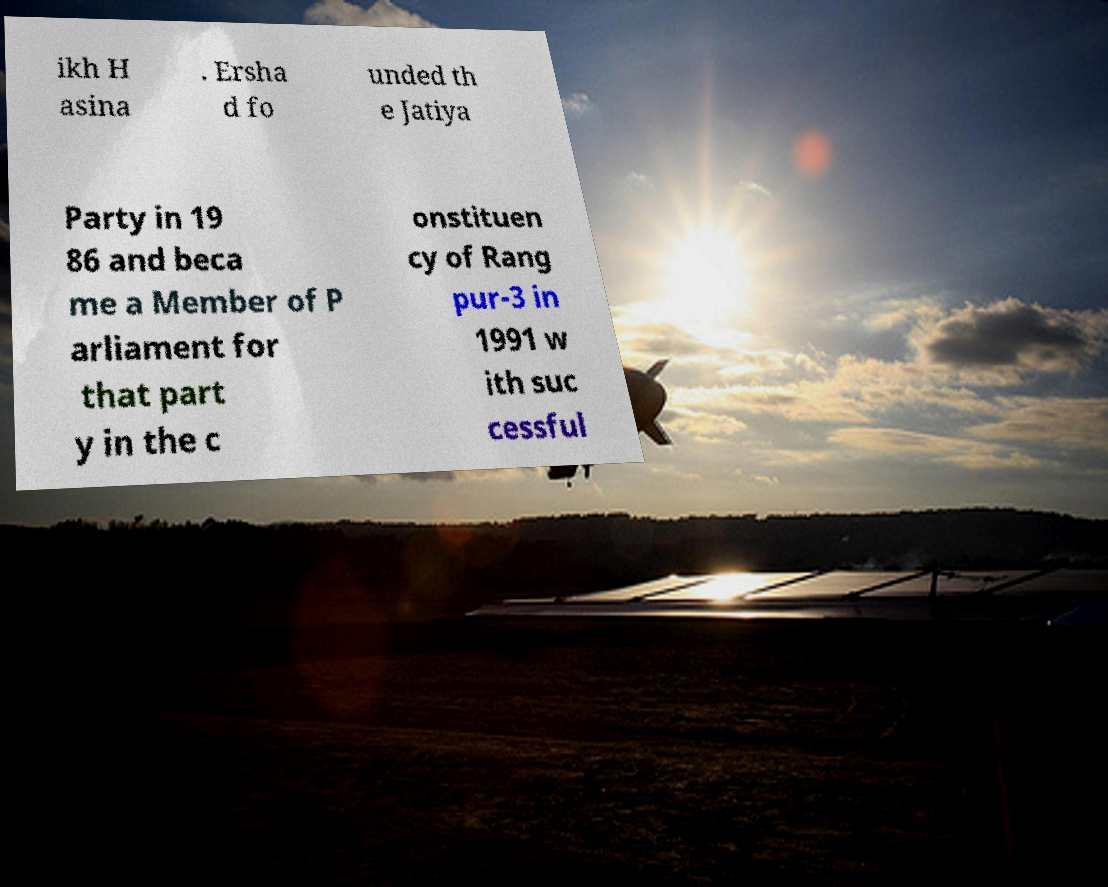Could you assist in decoding the text presented in this image and type it out clearly? ikh H asina . Ersha d fo unded th e Jatiya Party in 19 86 and beca me a Member of P arliament for that part y in the c onstituen cy of Rang pur-3 in 1991 w ith suc cessful 